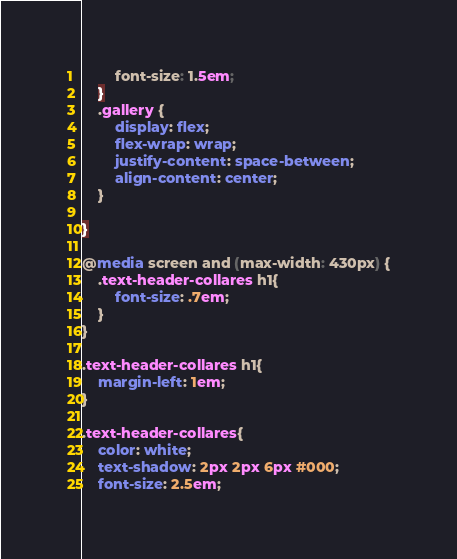Convert code to text. <code><loc_0><loc_0><loc_500><loc_500><_CSS_>        font-size: 1.5em;
    }
    .gallery {
        display: flex;
        flex-wrap: wrap;
        justify-content: space-between;
        align-content: center;
    }

}

@media screen and (max-width: 430px) {
    .text-header-collares h1{
        font-size: .7em;
    }
}

.text-header-collares h1{
    margin-left: 1em;
}

.text-header-collares{
    color: white;
    text-shadow: 2px 2px 6px #000;
    font-size: 2.5em;</code> 